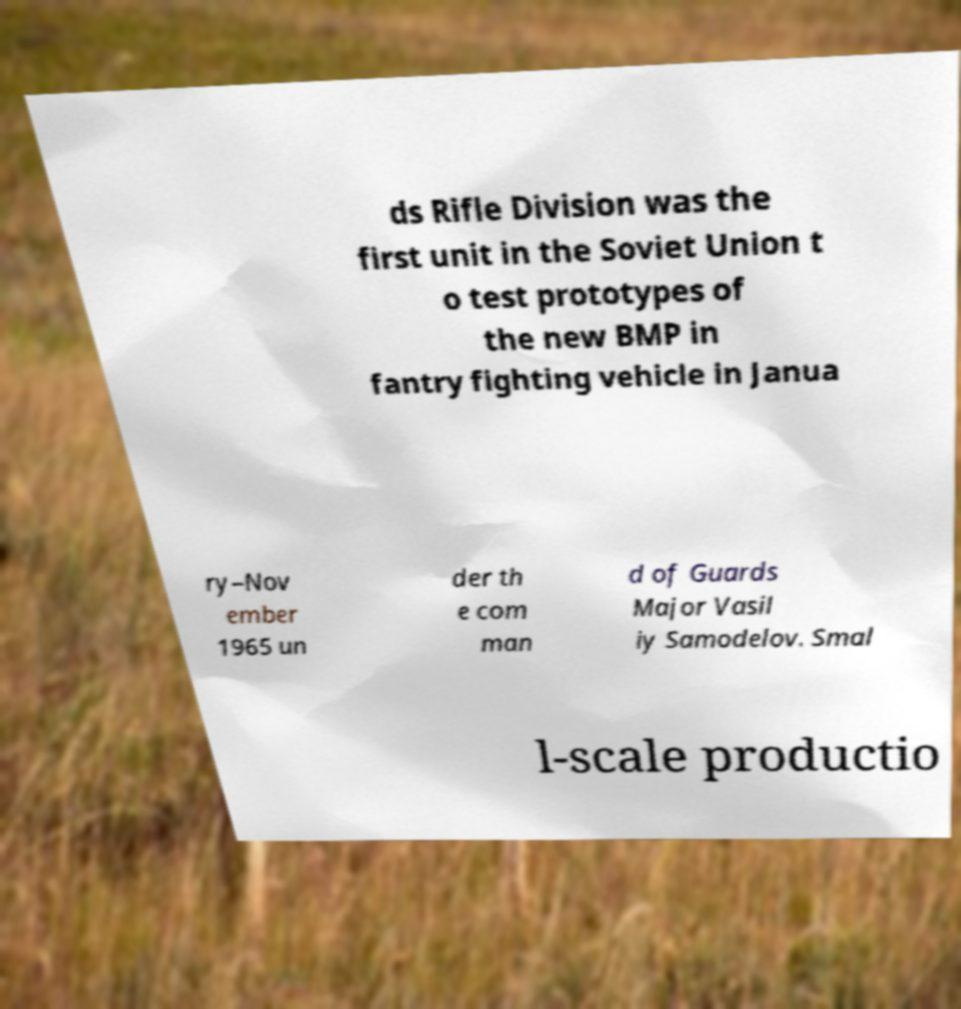I need the written content from this picture converted into text. Can you do that? ds Rifle Division was the first unit in the Soviet Union t o test prototypes of the new BMP in fantry fighting vehicle in Janua ry–Nov ember 1965 un der th e com man d of Guards Major Vasil iy Samodelov. Smal l-scale productio 